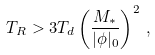<formula> <loc_0><loc_0><loc_500><loc_500>T _ { R } > 3 T _ { d } \left ( \frac { M _ { * } } { | \phi | _ { 0 } } \right ) ^ { 2 } \, ,</formula> 